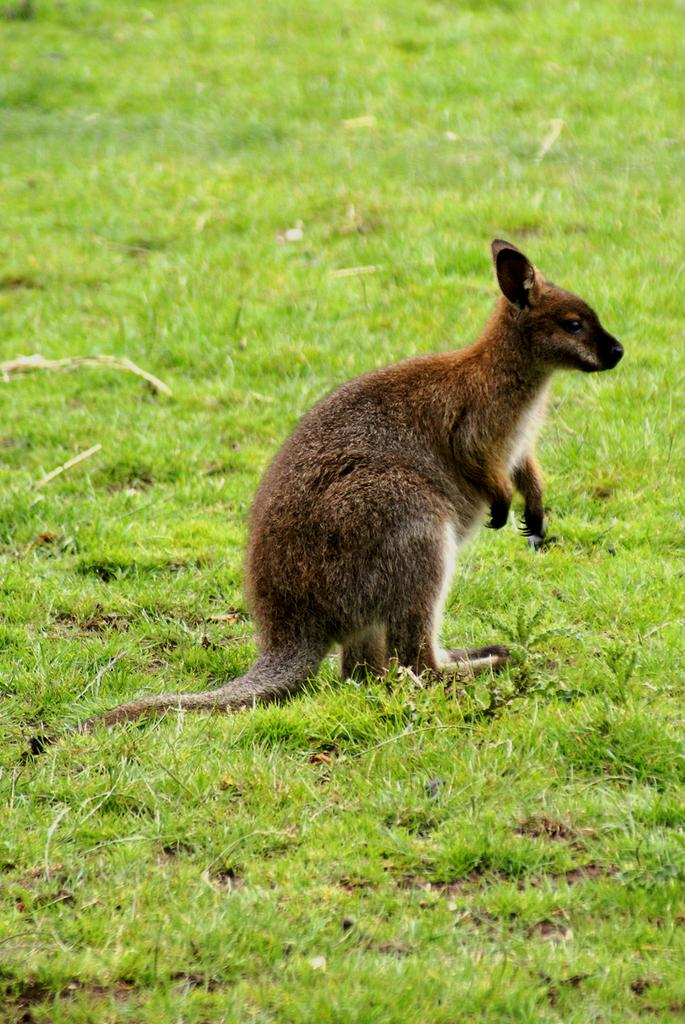What animal is present in the image? There is a kangaroo in the image. What is the kangaroo standing on in the image? The kangaroo is on the surface of the grass. What type of jam is the kangaroo spreading on the bread in the image? There is no bread or jam present in the image; it only features a kangaroo on the grass. 